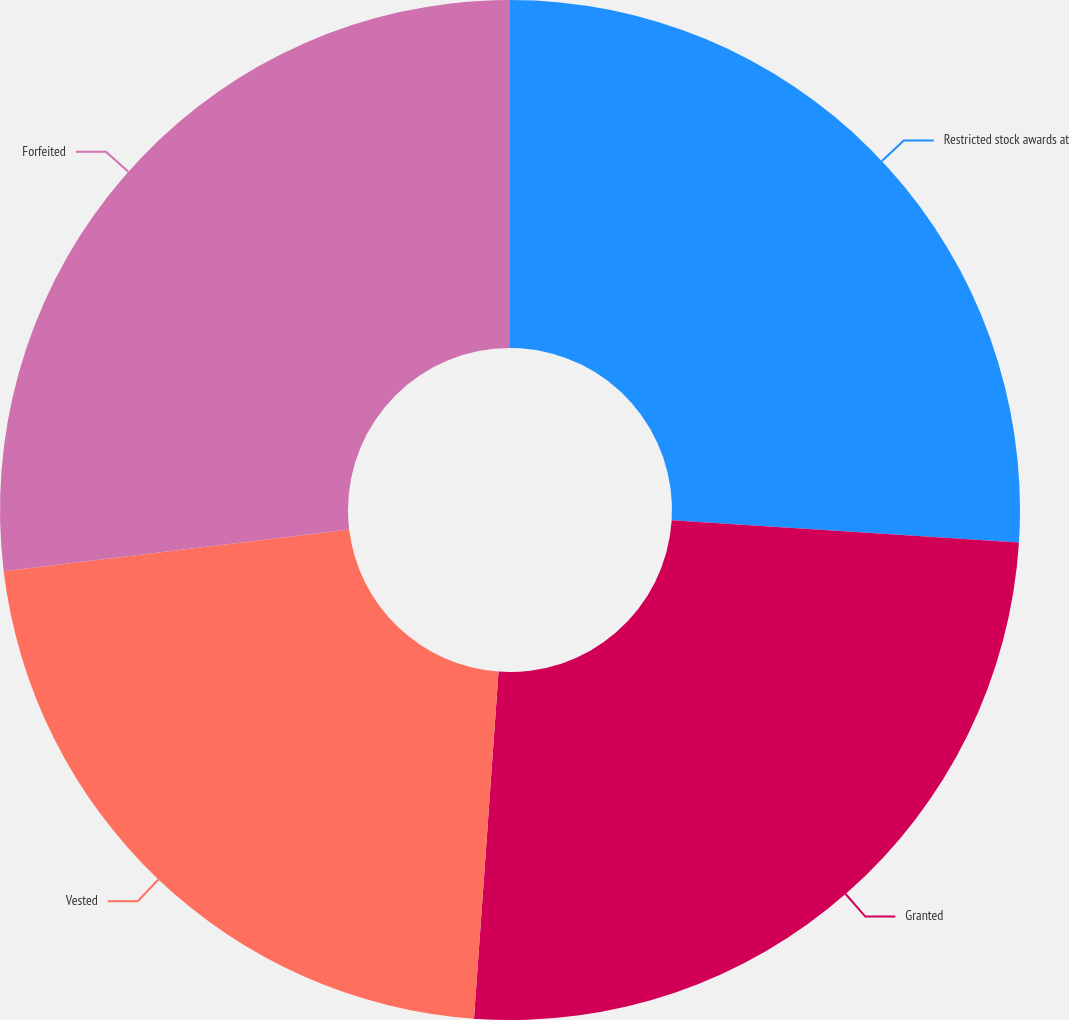Convert chart. <chart><loc_0><loc_0><loc_500><loc_500><pie_chart><fcel>Restricted stock awards at<fcel>Granted<fcel>Vested<fcel>Forfeited<nl><fcel>26.01%<fcel>25.11%<fcel>21.96%<fcel>26.91%<nl></chart> 